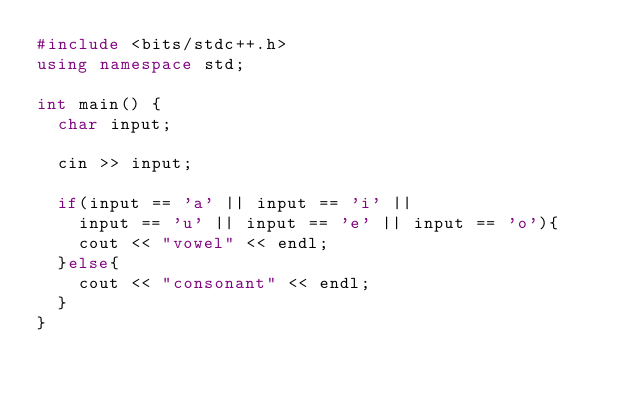<code> <loc_0><loc_0><loc_500><loc_500><_C++_>#include <bits/stdc++.h>
using namespace std;
 
int main() {
  char input;
  
  cin >> input;
  
  if(input == 'a' || input == 'i' || 
    input == 'u' || input == 'e' || input == 'o'){
  	cout << "vowel" << endl;
  }else{
  	cout << "consonant" << endl;
  }
}</code> 